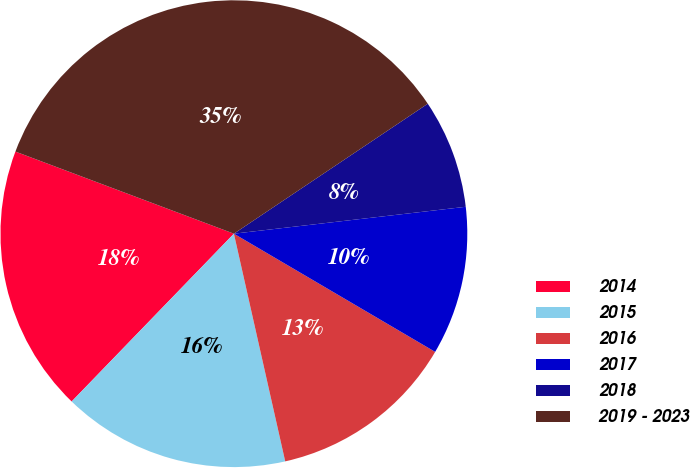Convert chart. <chart><loc_0><loc_0><loc_500><loc_500><pie_chart><fcel>2014<fcel>2015<fcel>2016<fcel>2017<fcel>2018<fcel>2019 - 2023<nl><fcel>18.49%<fcel>15.76%<fcel>13.02%<fcel>10.29%<fcel>7.56%<fcel>34.88%<nl></chart> 